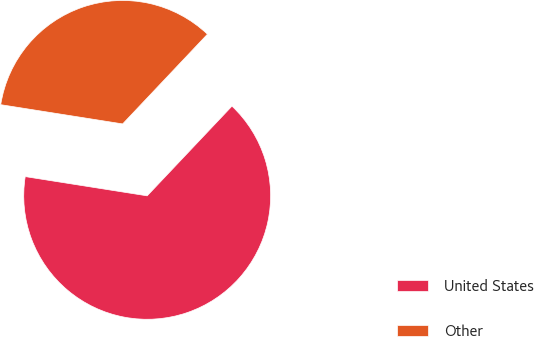Convert chart. <chart><loc_0><loc_0><loc_500><loc_500><pie_chart><fcel>United States<fcel>Other<nl><fcel>65.44%<fcel>34.56%<nl></chart> 